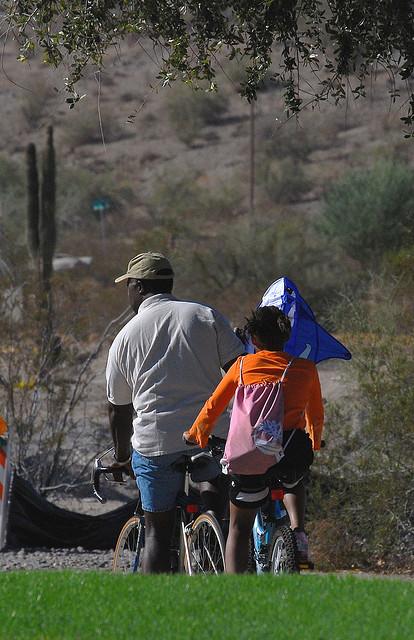How many adults are shown?
Concise answer only. 1. What is the object in front of these people?
Quick response, please. Kite. What color is the woman's shirt?
Concise answer only. Orange. Is it snowing?
Be succinct. No. What color is the grass?
Keep it brief. Green. 